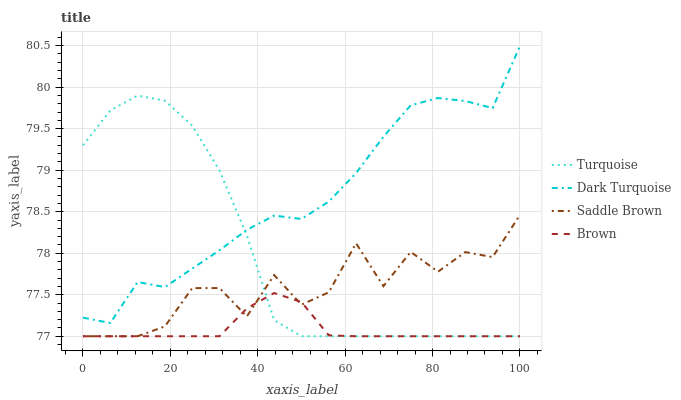Does Brown have the minimum area under the curve?
Answer yes or no. Yes. Does Dark Turquoise have the maximum area under the curve?
Answer yes or no. Yes. Does Turquoise have the minimum area under the curve?
Answer yes or no. No. Does Turquoise have the maximum area under the curve?
Answer yes or no. No. Is Brown the smoothest?
Answer yes or no. Yes. Is Saddle Brown the roughest?
Answer yes or no. Yes. Is Turquoise the smoothest?
Answer yes or no. No. Is Turquoise the roughest?
Answer yes or no. No. Does Turquoise have the lowest value?
Answer yes or no. Yes. Does Dark Turquoise have the highest value?
Answer yes or no. Yes. Does Turquoise have the highest value?
Answer yes or no. No. Is Brown less than Dark Turquoise?
Answer yes or no. Yes. Is Dark Turquoise greater than Saddle Brown?
Answer yes or no. Yes. Does Turquoise intersect Dark Turquoise?
Answer yes or no. Yes. Is Turquoise less than Dark Turquoise?
Answer yes or no. No. Is Turquoise greater than Dark Turquoise?
Answer yes or no. No. Does Brown intersect Dark Turquoise?
Answer yes or no. No. 